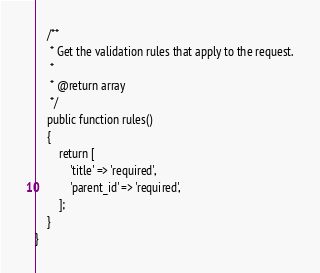<code> <loc_0><loc_0><loc_500><loc_500><_PHP_>
    /**
     * Get the validation rules that apply to the request.
     *
     * @return array
     */
    public function rules()
    {
        return [
            'title' => 'required',
            'parent_id' => 'required',
        ];
    }
}
</code> 